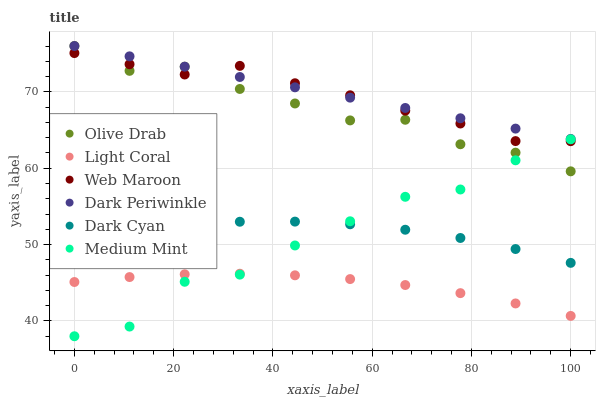Does Light Coral have the minimum area under the curve?
Answer yes or no. Yes. Does Dark Periwinkle have the maximum area under the curve?
Answer yes or no. Yes. Does Web Maroon have the minimum area under the curve?
Answer yes or no. No. Does Web Maroon have the maximum area under the curve?
Answer yes or no. No. Is Dark Periwinkle the smoothest?
Answer yes or no. Yes. Is Medium Mint the roughest?
Answer yes or no. Yes. Is Web Maroon the smoothest?
Answer yes or no. No. Is Web Maroon the roughest?
Answer yes or no. No. Does Medium Mint have the lowest value?
Answer yes or no. Yes. Does Web Maroon have the lowest value?
Answer yes or no. No. Does Olive Drab have the highest value?
Answer yes or no. Yes. Does Web Maroon have the highest value?
Answer yes or no. No. Is Dark Cyan less than Dark Periwinkle?
Answer yes or no. Yes. Is Olive Drab greater than Dark Cyan?
Answer yes or no. Yes. Does Dark Periwinkle intersect Olive Drab?
Answer yes or no. Yes. Is Dark Periwinkle less than Olive Drab?
Answer yes or no. No. Is Dark Periwinkle greater than Olive Drab?
Answer yes or no. No. Does Dark Cyan intersect Dark Periwinkle?
Answer yes or no. No. 